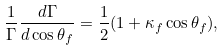Convert formula to latex. <formula><loc_0><loc_0><loc_500><loc_500>\frac { 1 } { \Gamma } \frac { d \Gamma } { d \cos \theta _ { f } } = \frac { 1 } { 2 } ( 1 + \kappa _ { f } \cos \theta _ { f } ) ,</formula> 